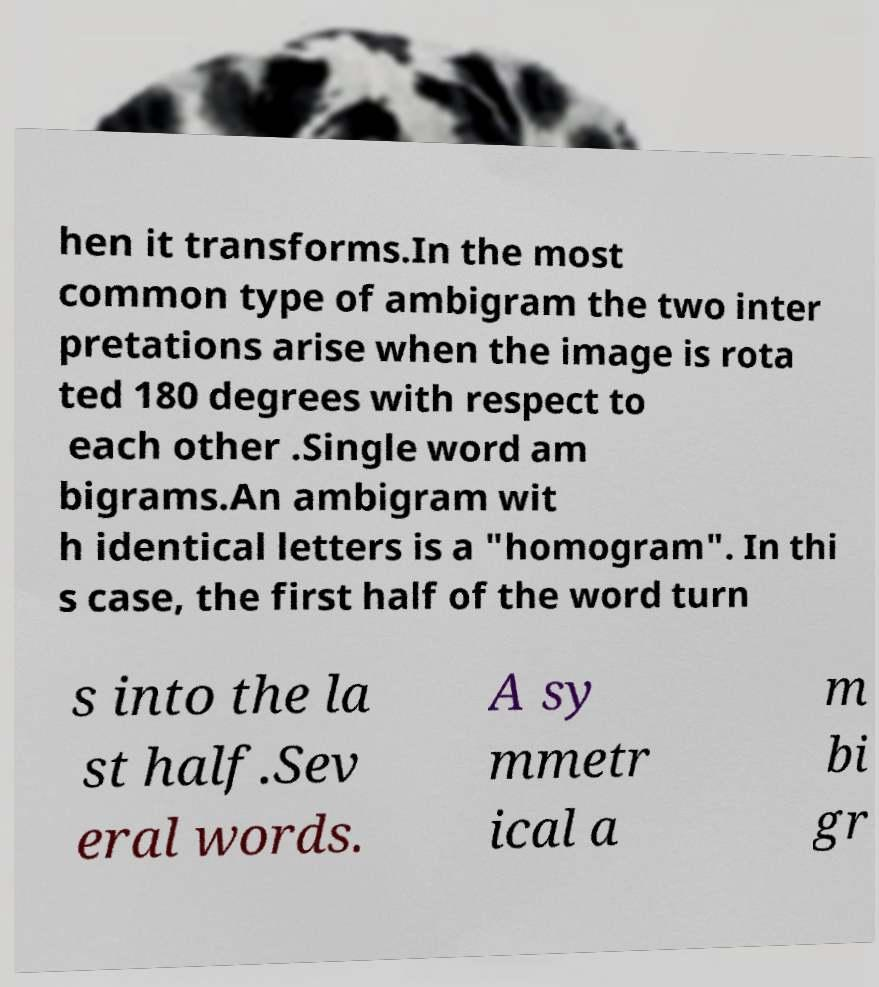Can you accurately transcribe the text from the provided image for me? hen it transforms.In the most common type of ambigram the two inter pretations arise when the image is rota ted 180 degrees with respect to each other .Single word am bigrams.An ambigram wit h identical letters is a "homogram". In thi s case, the first half of the word turn s into the la st half.Sev eral words. A sy mmetr ical a m bi gr 